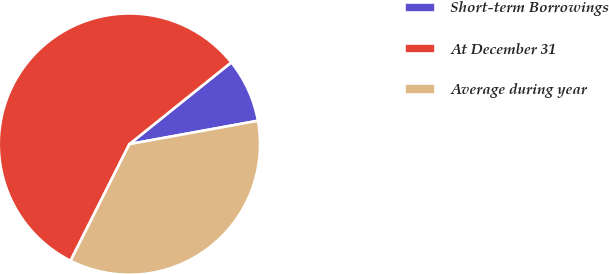Convert chart. <chart><loc_0><loc_0><loc_500><loc_500><pie_chart><fcel>Short-term Borrowings<fcel>At December 31<fcel>Average during year<nl><fcel>7.9%<fcel>56.8%<fcel>35.3%<nl></chart> 